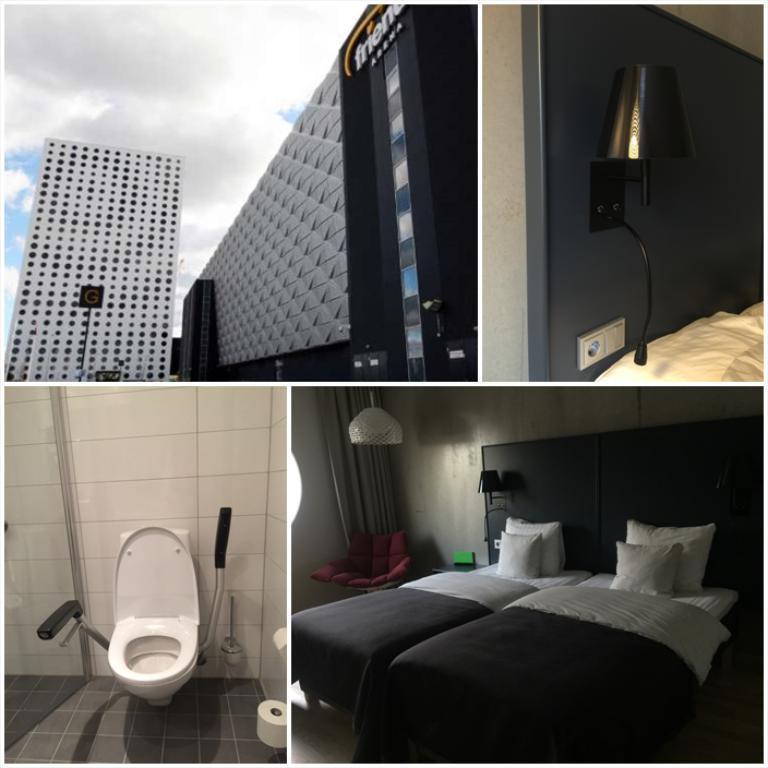Could you give a brief overview of what you see in this image? In this image I can see the collage picture in which I can see a lamp, a grey colored wall, a switch board, a bed, few pillows on the bed, a toilet seat which is white in color, a tissue roll, few buildings and the sky. 